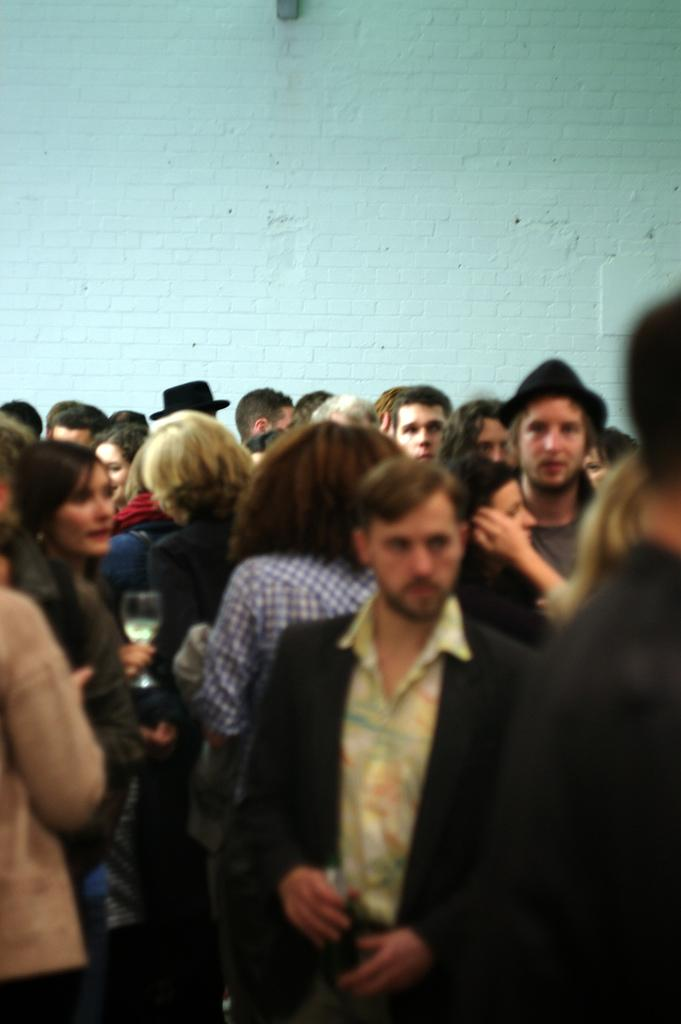How many people are in the image? There is a group of people in the image, but the exact number cannot be determined from the provided facts. What can be seen in the background of the image? There is a wall in the background of the image. What type of jar is being used by the people in the image? There is no jar present in the image. How many chairs are visible in the image? The provided facts do not mention any chairs in the image. 